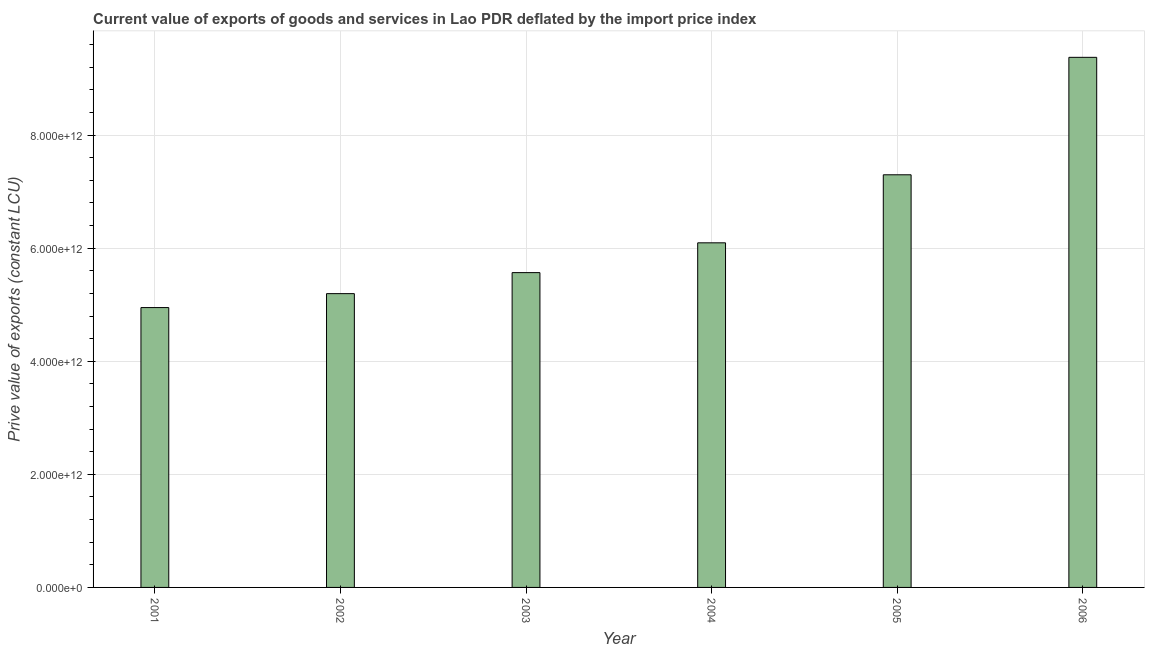Does the graph contain any zero values?
Keep it short and to the point. No. Does the graph contain grids?
Provide a short and direct response. Yes. What is the title of the graph?
Your answer should be compact. Current value of exports of goods and services in Lao PDR deflated by the import price index. What is the label or title of the X-axis?
Offer a very short reply. Year. What is the label or title of the Y-axis?
Provide a succinct answer. Prive value of exports (constant LCU). What is the price value of exports in 2004?
Provide a short and direct response. 6.09e+12. Across all years, what is the maximum price value of exports?
Offer a terse response. 9.37e+12. Across all years, what is the minimum price value of exports?
Provide a short and direct response. 4.95e+12. In which year was the price value of exports maximum?
Provide a succinct answer. 2006. What is the sum of the price value of exports?
Make the answer very short. 3.85e+13. What is the difference between the price value of exports in 2001 and 2003?
Make the answer very short. -6.18e+11. What is the average price value of exports per year?
Provide a short and direct response. 6.41e+12. What is the median price value of exports?
Your response must be concise. 5.83e+12. Do a majority of the years between 2004 and 2005 (inclusive) have price value of exports greater than 8400000000000 LCU?
Ensure brevity in your answer.  No. What is the ratio of the price value of exports in 2002 to that in 2004?
Give a very brief answer. 0.85. Is the price value of exports in 2002 less than that in 2003?
Ensure brevity in your answer.  Yes. What is the difference between the highest and the second highest price value of exports?
Give a very brief answer. 2.08e+12. Is the sum of the price value of exports in 2002 and 2005 greater than the maximum price value of exports across all years?
Ensure brevity in your answer.  Yes. What is the difference between the highest and the lowest price value of exports?
Provide a succinct answer. 4.43e+12. In how many years, is the price value of exports greater than the average price value of exports taken over all years?
Keep it short and to the point. 2. Are all the bars in the graph horizontal?
Keep it short and to the point. No. What is the difference between two consecutive major ticks on the Y-axis?
Your response must be concise. 2.00e+12. Are the values on the major ticks of Y-axis written in scientific E-notation?
Keep it short and to the point. Yes. What is the Prive value of exports (constant LCU) of 2001?
Give a very brief answer. 4.95e+12. What is the Prive value of exports (constant LCU) in 2002?
Give a very brief answer. 5.20e+12. What is the Prive value of exports (constant LCU) of 2003?
Your response must be concise. 5.57e+12. What is the Prive value of exports (constant LCU) in 2004?
Your answer should be very brief. 6.09e+12. What is the Prive value of exports (constant LCU) of 2005?
Provide a succinct answer. 7.30e+12. What is the Prive value of exports (constant LCU) in 2006?
Your answer should be compact. 9.37e+12. What is the difference between the Prive value of exports (constant LCU) in 2001 and 2002?
Your response must be concise. -2.46e+11. What is the difference between the Prive value of exports (constant LCU) in 2001 and 2003?
Your response must be concise. -6.18e+11. What is the difference between the Prive value of exports (constant LCU) in 2001 and 2004?
Keep it short and to the point. -1.14e+12. What is the difference between the Prive value of exports (constant LCU) in 2001 and 2005?
Your response must be concise. -2.35e+12. What is the difference between the Prive value of exports (constant LCU) in 2001 and 2006?
Your answer should be compact. -4.43e+12. What is the difference between the Prive value of exports (constant LCU) in 2002 and 2003?
Keep it short and to the point. -3.72e+11. What is the difference between the Prive value of exports (constant LCU) in 2002 and 2004?
Offer a very short reply. -8.99e+11. What is the difference between the Prive value of exports (constant LCU) in 2002 and 2005?
Give a very brief answer. -2.10e+12. What is the difference between the Prive value of exports (constant LCU) in 2002 and 2006?
Provide a short and direct response. -4.18e+12. What is the difference between the Prive value of exports (constant LCU) in 2003 and 2004?
Provide a short and direct response. -5.27e+11. What is the difference between the Prive value of exports (constant LCU) in 2003 and 2005?
Keep it short and to the point. -1.73e+12. What is the difference between the Prive value of exports (constant LCU) in 2003 and 2006?
Ensure brevity in your answer.  -3.81e+12. What is the difference between the Prive value of exports (constant LCU) in 2004 and 2005?
Make the answer very short. -1.20e+12. What is the difference between the Prive value of exports (constant LCU) in 2004 and 2006?
Give a very brief answer. -3.28e+12. What is the difference between the Prive value of exports (constant LCU) in 2005 and 2006?
Provide a short and direct response. -2.08e+12. What is the ratio of the Prive value of exports (constant LCU) in 2001 to that in 2002?
Your response must be concise. 0.95. What is the ratio of the Prive value of exports (constant LCU) in 2001 to that in 2003?
Your answer should be very brief. 0.89. What is the ratio of the Prive value of exports (constant LCU) in 2001 to that in 2004?
Offer a very short reply. 0.81. What is the ratio of the Prive value of exports (constant LCU) in 2001 to that in 2005?
Offer a terse response. 0.68. What is the ratio of the Prive value of exports (constant LCU) in 2001 to that in 2006?
Your answer should be compact. 0.53. What is the ratio of the Prive value of exports (constant LCU) in 2002 to that in 2003?
Your answer should be compact. 0.93. What is the ratio of the Prive value of exports (constant LCU) in 2002 to that in 2004?
Provide a succinct answer. 0.85. What is the ratio of the Prive value of exports (constant LCU) in 2002 to that in 2005?
Your response must be concise. 0.71. What is the ratio of the Prive value of exports (constant LCU) in 2002 to that in 2006?
Make the answer very short. 0.55. What is the ratio of the Prive value of exports (constant LCU) in 2003 to that in 2004?
Your answer should be very brief. 0.91. What is the ratio of the Prive value of exports (constant LCU) in 2003 to that in 2005?
Make the answer very short. 0.76. What is the ratio of the Prive value of exports (constant LCU) in 2003 to that in 2006?
Offer a very short reply. 0.59. What is the ratio of the Prive value of exports (constant LCU) in 2004 to that in 2005?
Your answer should be compact. 0.83. What is the ratio of the Prive value of exports (constant LCU) in 2004 to that in 2006?
Keep it short and to the point. 0.65. What is the ratio of the Prive value of exports (constant LCU) in 2005 to that in 2006?
Offer a very short reply. 0.78. 